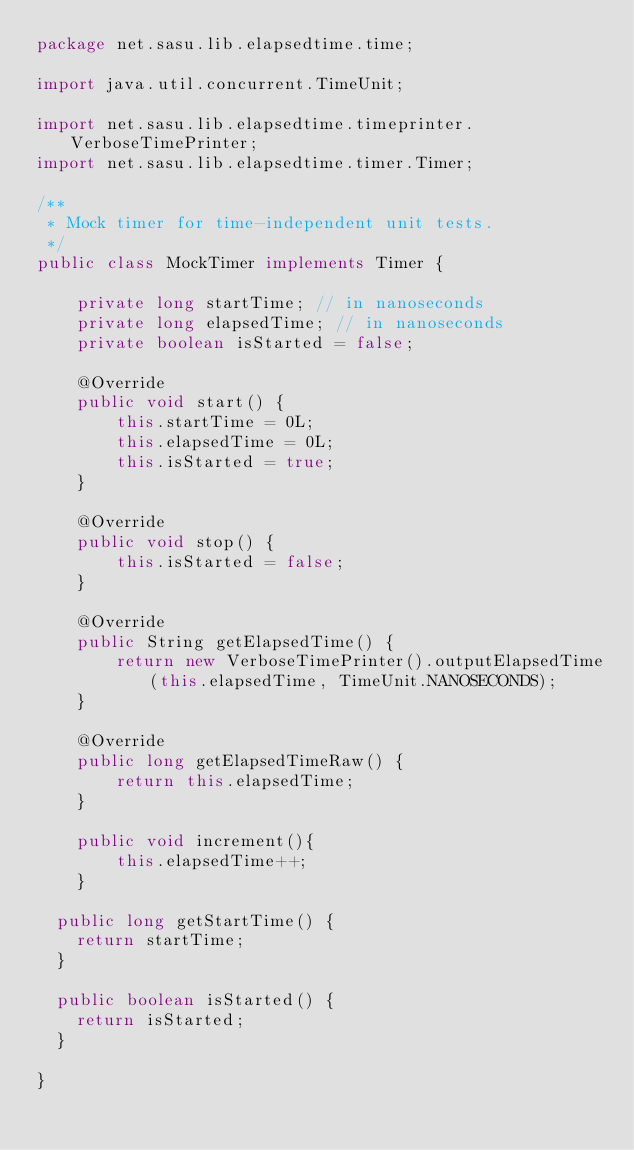Convert code to text. <code><loc_0><loc_0><loc_500><loc_500><_Java_>package net.sasu.lib.elapsedtime.time;

import java.util.concurrent.TimeUnit;

import net.sasu.lib.elapsedtime.timeprinter.VerboseTimePrinter;
import net.sasu.lib.elapsedtime.timer.Timer;

/**
 * Mock timer for time-independent unit tests.
 */
public class MockTimer implements Timer {

    private long startTime; // in nanoseconds
    private long elapsedTime; // in nanoseconds
    private boolean isStarted = false;
    
    @Override
    public void start() {
        this.startTime = 0L;
        this.elapsedTime = 0L;
        this.isStarted = true;
    }

    @Override
    public void stop() {
        this.isStarted = false;
    }

    @Override
    public String getElapsedTime() {
        return new VerboseTimePrinter().outputElapsedTime(this.elapsedTime, TimeUnit.NANOSECONDS);
    }

    @Override
    public long getElapsedTimeRaw() {
        return this.elapsedTime;
    }

    public void increment(){
        this.elapsedTime++;
    }

	public long getStartTime() {
		return startTime;
	}

	public boolean isStarted() {
		return isStarted;
	}

}
</code> 